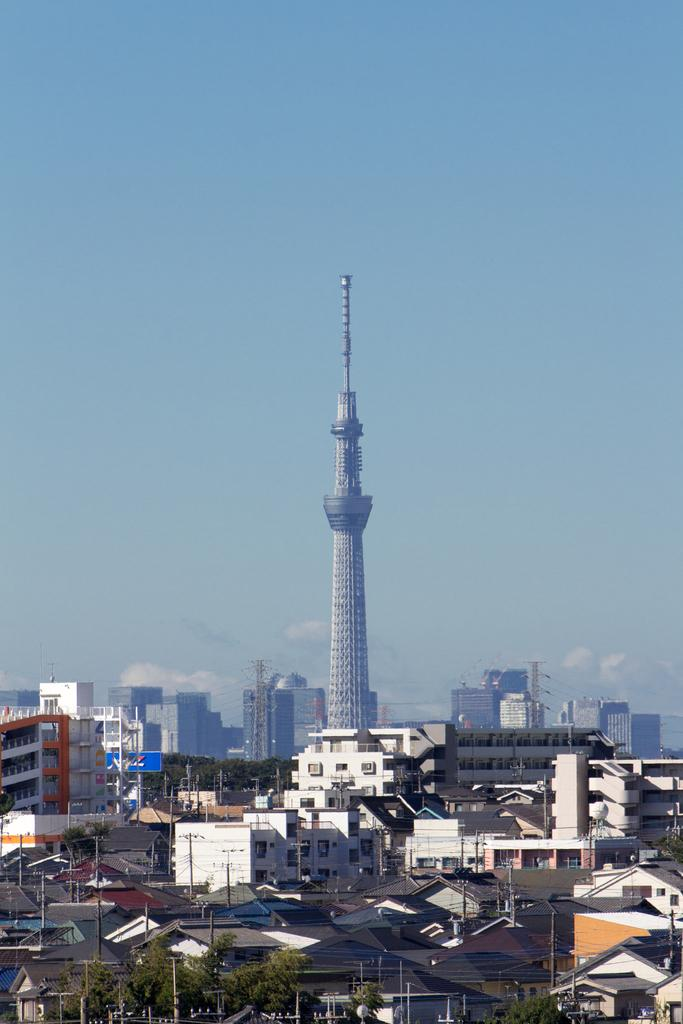What type of view is shown in the image? The image is an aerial view of a city. What structures can be seen in the image? There are buildings, trees, and poles in the image. Can you identify any specific type of building in the image? Yes, there is a skyscraper in the image. What is the weather like in the image? The sky is sunny in the image. What type of brick is used to build the connection between the trees in the image? There is no mention of bricks or connections between trees in the image. The image primarily features buildings, trees, poles, and a skyscraper. 